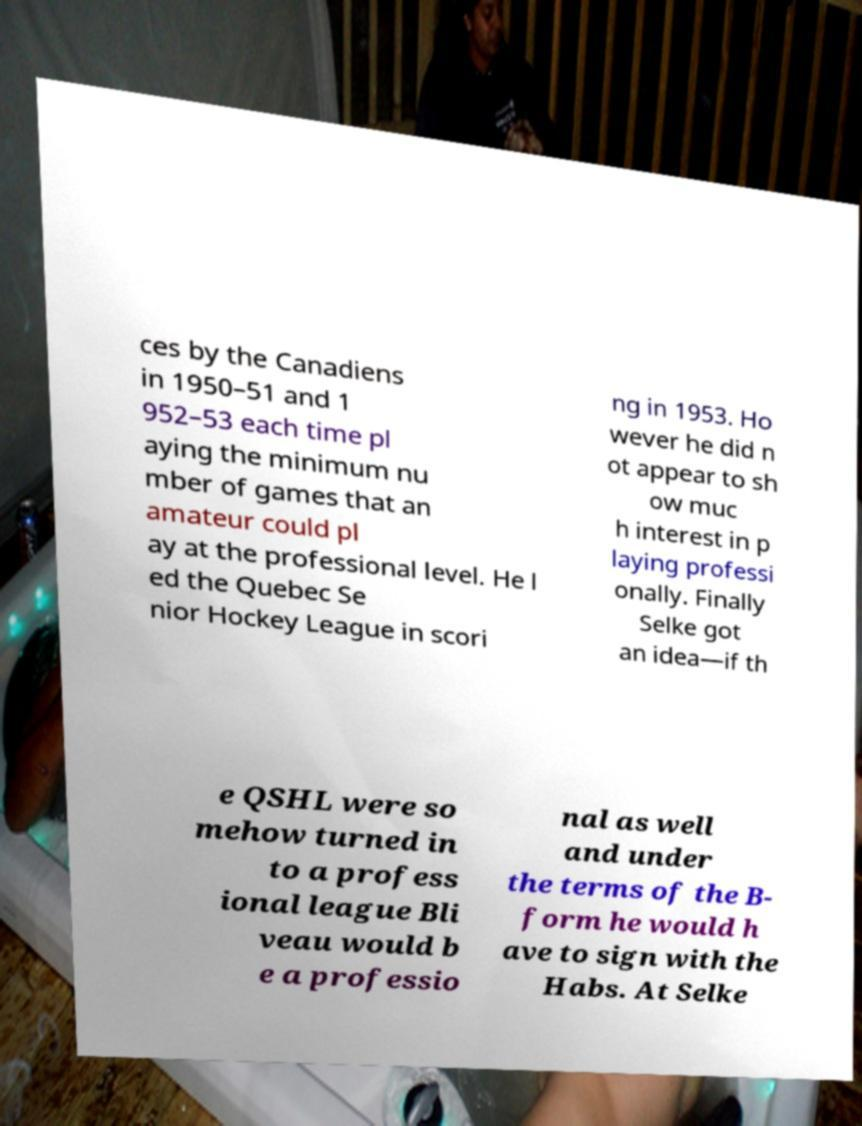Can you read and provide the text displayed in the image?This photo seems to have some interesting text. Can you extract and type it out for me? ces by the Canadiens in 1950–51 and 1 952–53 each time pl aying the minimum nu mber of games that an amateur could pl ay at the professional level. He l ed the Quebec Se nior Hockey League in scori ng in 1953. Ho wever he did n ot appear to sh ow muc h interest in p laying professi onally. Finally Selke got an idea—if th e QSHL were so mehow turned in to a profess ional league Bli veau would b e a professio nal as well and under the terms of the B- form he would h ave to sign with the Habs. At Selke 